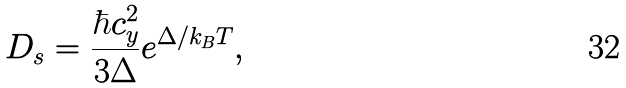Convert formula to latex. <formula><loc_0><loc_0><loc_500><loc_500>D _ { s } = \frac { \hbar { c } _ { y } ^ { 2 } } { 3 \Delta } e ^ { \Delta / k _ { B } T } ,</formula> 